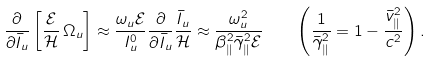Convert formula to latex. <formula><loc_0><loc_0><loc_500><loc_500>\frac { \partial } { \partial { \bar { I } _ { u } } } \left [ \frac { \mathcal { E } } { \mathcal { H } } \, \Omega _ { u } \right ] \approx \frac { \omega _ { u } \mathcal { E } } { I _ { u } ^ { 0 } } \frac { \partial } { \partial { \bar { I } _ { u } } } \frac { { \bar { I } _ { u } } } { \mathcal { H } } \approx \frac { \omega _ { u } ^ { 2 } } { \beta _ { \| } ^ { 2 } \bar { \gamma } _ { \| } ^ { 2 } \mathcal { E } } \quad \left ( \frac { 1 } { \bar { \gamma } _ { \| } ^ { 2 } } = 1 - \frac { \bar { v } _ { \| } ^ { 2 } } { c ^ { 2 } } \right ) .</formula> 